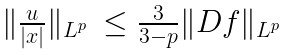<formula> <loc_0><loc_0><loc_500><loc_500>\begin{array} { l l } \| \frac { u } { | x | } \| _ { L ^ { p } } & \leq \frac { 3 } { 3 - p } \| D f \| _ { L ^ { p } } \end{array}</formula> 